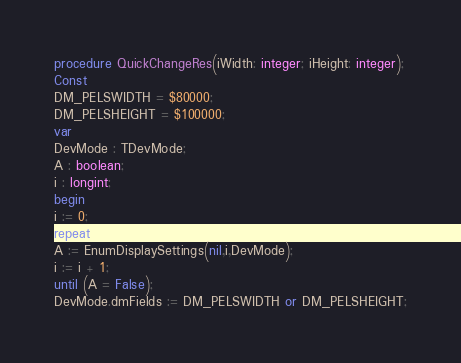<code> <loc_0><loc_0><loc_500><loc_500><_Pascal_>procedure QuickChangeRes(iWidth: integer; iHeight: integer);
Const
DM_PELSWIDTH = $80000;
DM_PELSHEIGHT = $100000;
var
DevMode : TDevMode;
A : boolean;
i : longint;
begin
i := 0;
repeat
A := EnumDisplaySettings(nil,i,DevMode);
i := i + 1;
until (A = False);
DevMode.dmFields := DM_PELSWIDTH or DM_PELSHEIGHT;</code> 